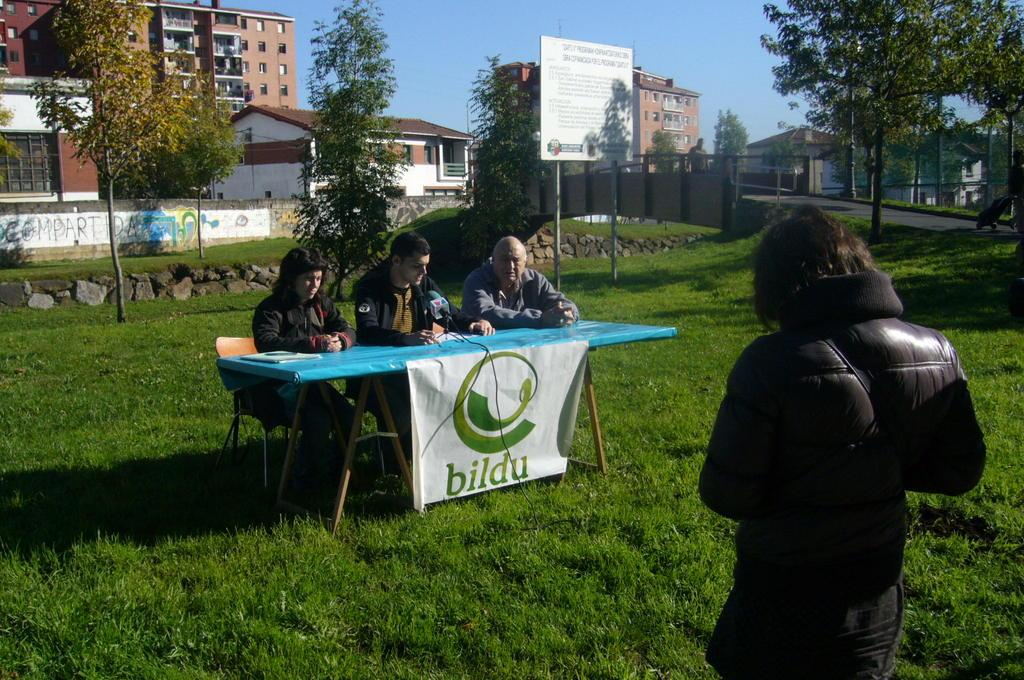<image>
Provide a brief description of the given image. the word bildu that has green writing on it 